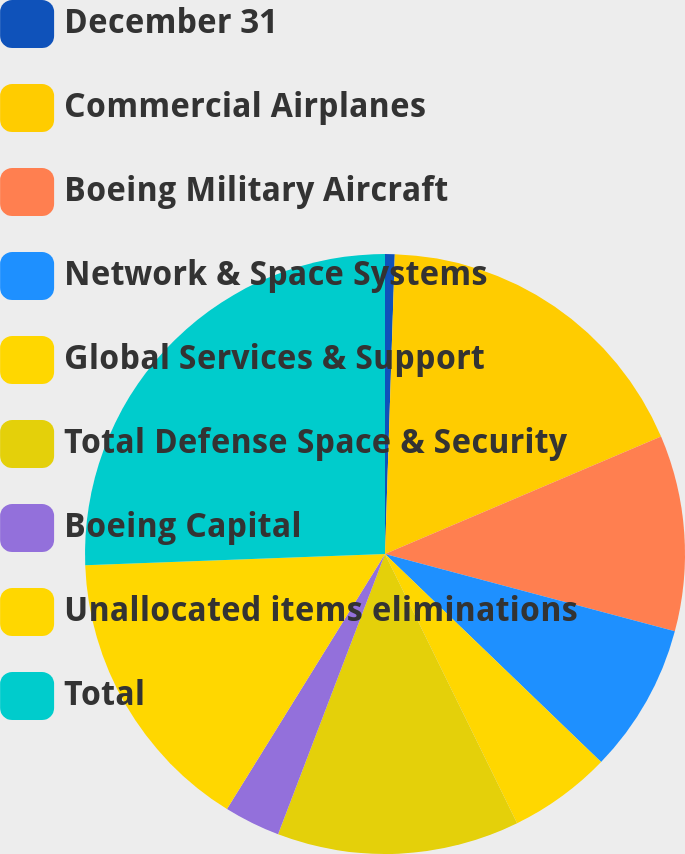<chart> <loc_0><loc_0><loc_500><loc_500><pie_chart><fcel>December 31<fcel>Commercial Airplanes<fcel>Boeing Military Aircraft<fcel>Network & Space Systems<fcel>Global Services & Support<fcel>Total Defense Space & Security<fcel>Boeing Capital<fcel>Unallocated items eliminations<fcel>Total<nl><fcel>0.52%<fcel>18.08%<fcel>10.55%<fcel>8.05%<fcel>5.54%<fcel>13.06%<fcel>3.03%<fcel>15.57%<fcel>25.6%<nl></chart> 